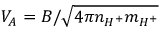Convert formula to latex. <formula><loc_0><loc_0><loc_500><loc_500>V _ { A } = { B } / { \sqrt { 4 \pi n _ { H ^ { + } } m _ { H ^ { + } } } }</formula> 